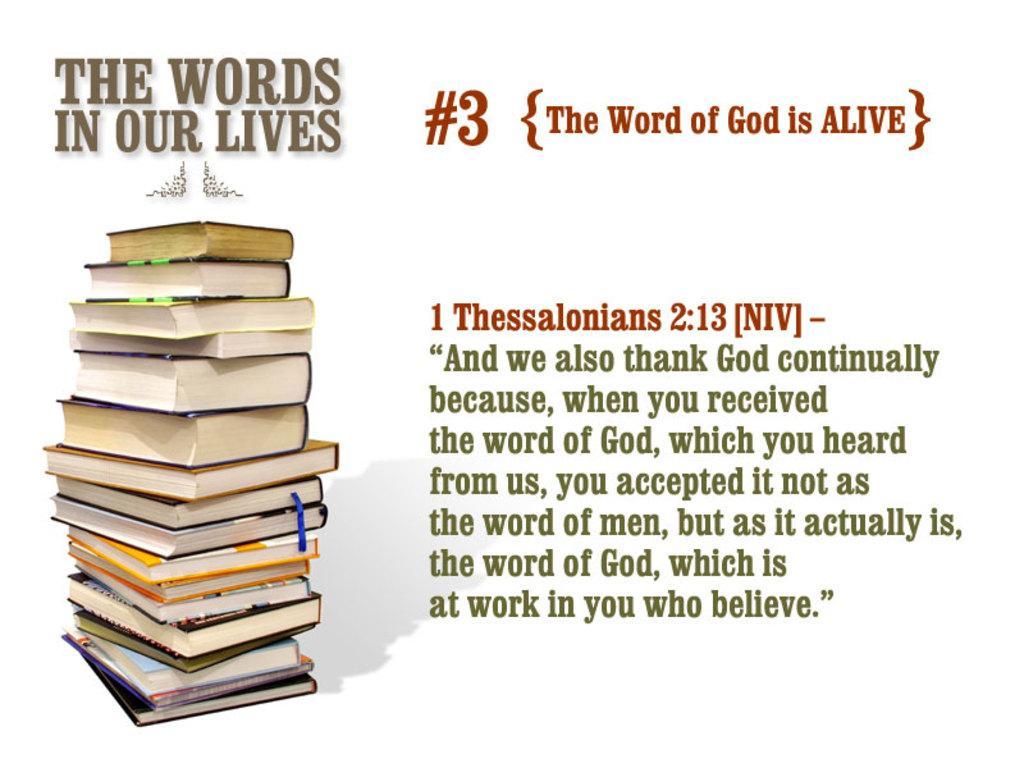Could you give a brief overview of what you see in this image? In this picture I can see the edited image. On the left I can see many books. On the right I can see the article. 